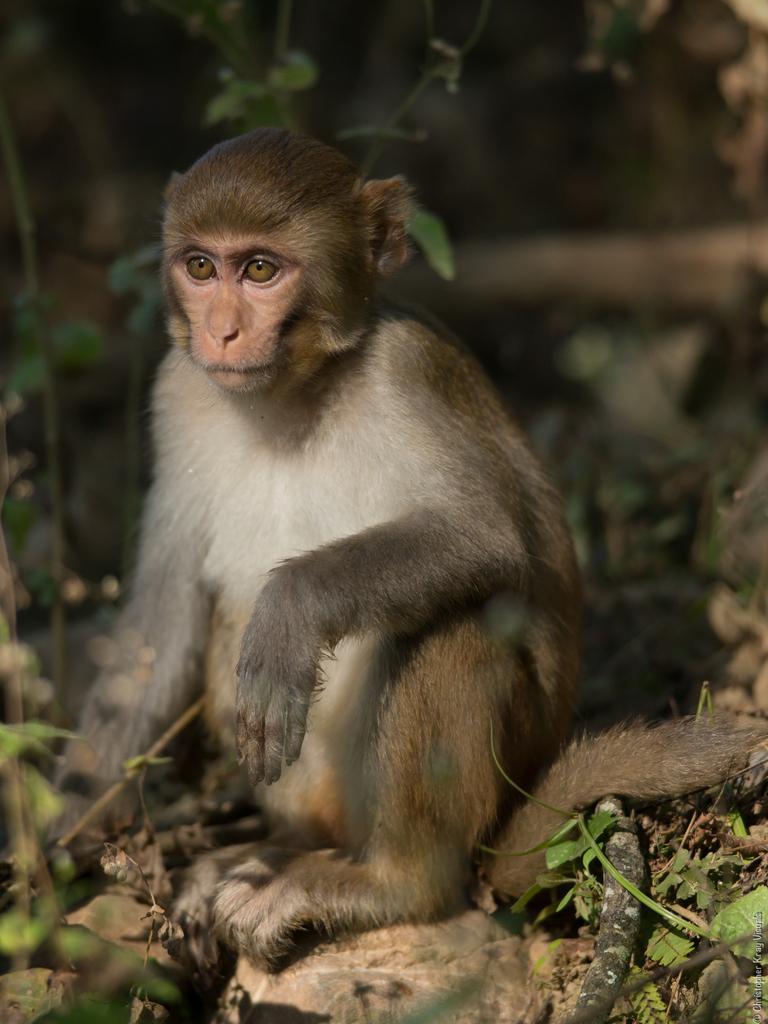Can you describe this image briefly? In this image a monkey is sitting on the ground facing towards the left side. At the bottom few leaves are visible. The background is blurred. 